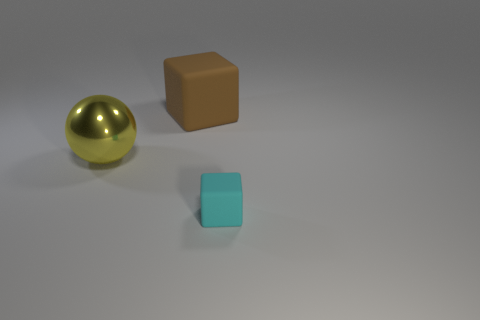Are there any other things that have the same size as the cyan matte object?
Provide a short and direct response. No. Do the small object and the large thing in front of the large matte block have the same material?
Offer a terse response. No. Are there more rubber things than things?
Your response must be concise. No. How many cylinders are brown objects or small cyan objects?
Your answer should be compact. 0. What color is the sphere?
Provide a succinct answer. Yellow. Is the size of the matte block behind the yellow ball the same as the block in front of the large rubber object?
Provide a succinct answer. No. Are there fewer big brown cubes than large objects?
Keep it short and to the point. Yes. There is a cyan rubber object; how many large yellow balls are to the right of it?
Offer a terse response. 0. What is the tiny thing made of?
Your answer should be compact. Rubber. Is the number of rubber cubes on the left side of the small matte object less than the number of things?
Ensure brevity in your answer.  Yes. 